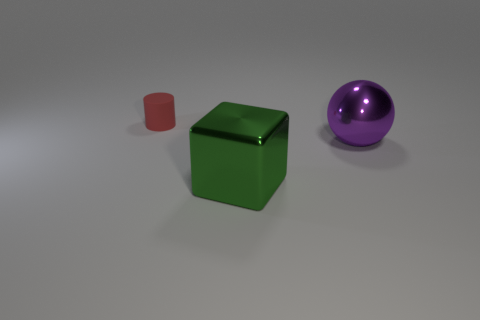Add 2 small brown cubes. How many objects exist? 5 Subtract all spheres. How many objects are left? 2 Subtract 0 green spheres. How many objects are left? 3 Subtract all big blue cylinders. Subtract all metal objects. How many objects are left? 1 Add 2 purple things. How many purple things are left? 3 Add 2 shiny balls. How many shiny balls exist? 3 